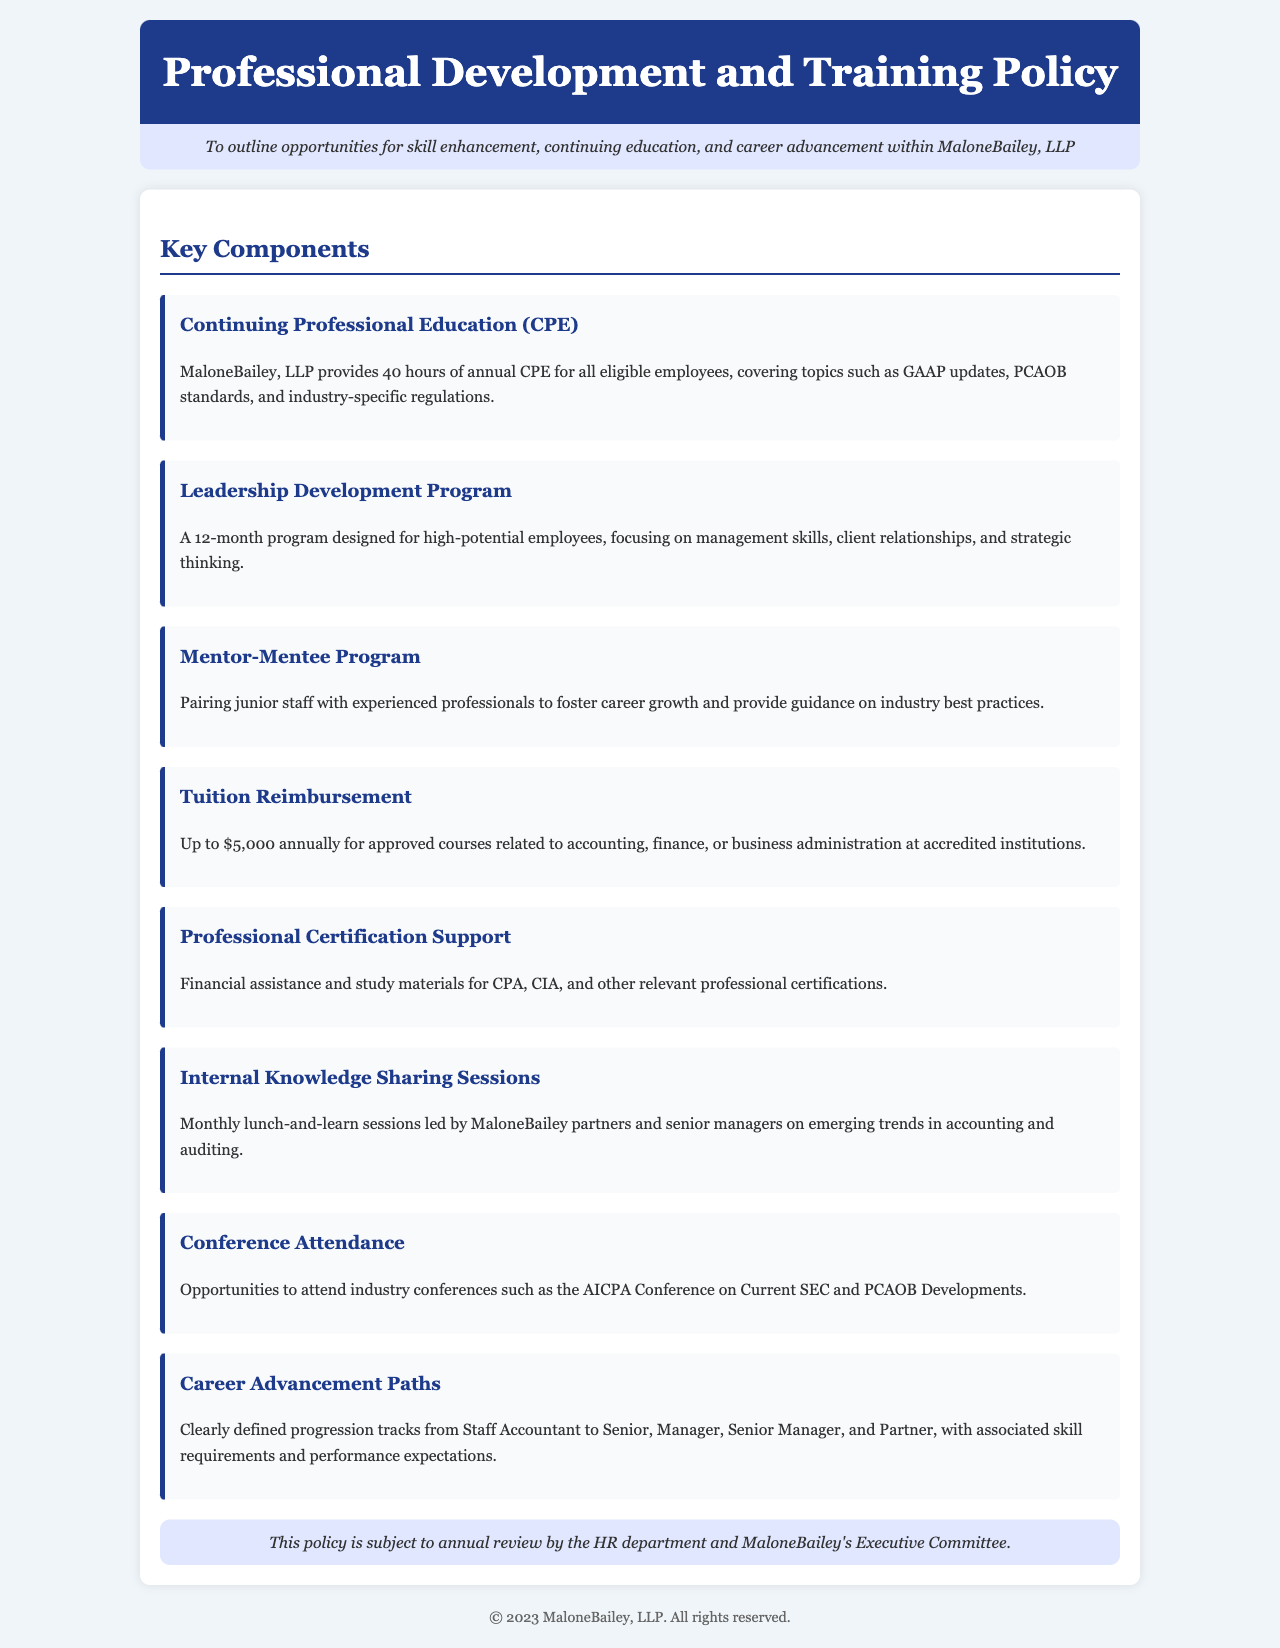What is the annual CPE requirement for employees? The document states that MaloneBailey, LLP provides 40 hours of annual CPE for all eligible employees.
Answer: 40 hours What is the monetary limit for tuition reimbursement? The policy outlines that MaloneBailey offers up to $5,000 annually for approved courses.
Answer: $5,000 How long is the Leadership Development Program? The document describes the Leadership Development Program as a 12-month program.
Answer: 12 months What type of programs are included in the Professional Certification Support? The document mentions financial assistance for CPA, CIA, and other relevant professional certifications.
Answer: CPA, CIA What is the purpose of the Mentor-Mentee Program? The policy indicates that the Mentor-Mentee Program is designed to foster career growth and provide guidance.
Answer: Foster career growth What opportunities does the document offer for internal knowledge sharing? The document describes internal knowledge sharing sessions as monthly lunch-and-learn sessions led by partners and senior managers.
Answer: Monthly lunch-and-learn sessions What are the career advancement paths mentioned in the policy? The document outlines clear progression tracks from Staff Accountant to Partner, specifying skill requirements and expectations.
Answer: From Staff Accountant to Partner How often is the policy reviewed? The document states that this policy is subject to annual review by HR and the Executive Committee.
Answer: Annual review 